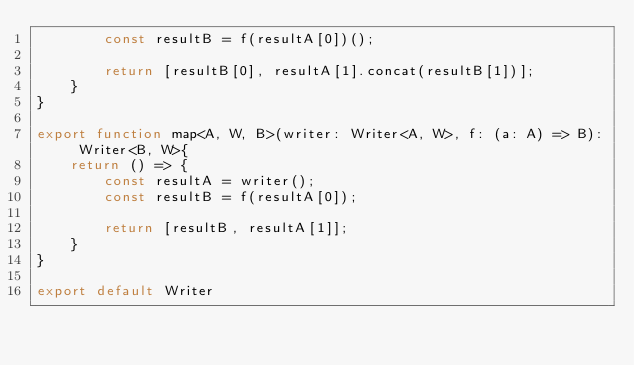<code> <loc_0><loc_0><loc_500><loc_500><_TypeScript_>        const resultB = f(resultA[0])();

        return [resultB[0], resultA[1].concat(resultB[1])];
    }
}

export function map<A, W, B>(writer: Writer<A, W>, f: (a: A) => B): Writer<B, W>{
    return () => {
        const resultA = writer();
        const resultB = f(resultA[0]);

        return [resultB, resultA[1]];
    }
}

export default Writer
</code> 